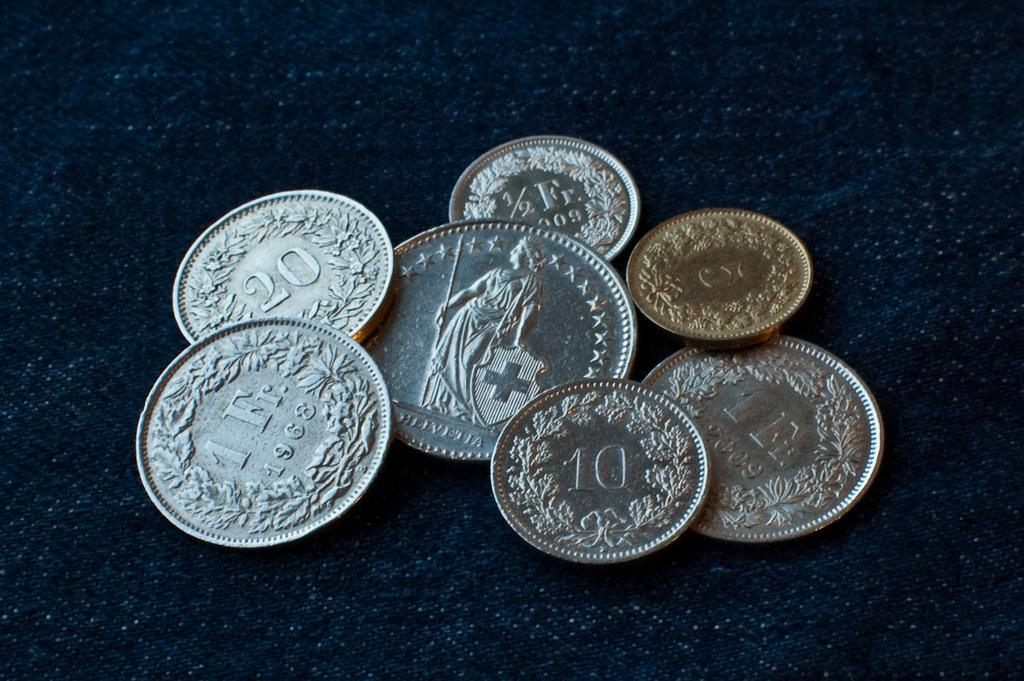<image>
Give a short and clear explanation of the subsequent image. A handful of coins have the years 1968 and 2009 on them. 